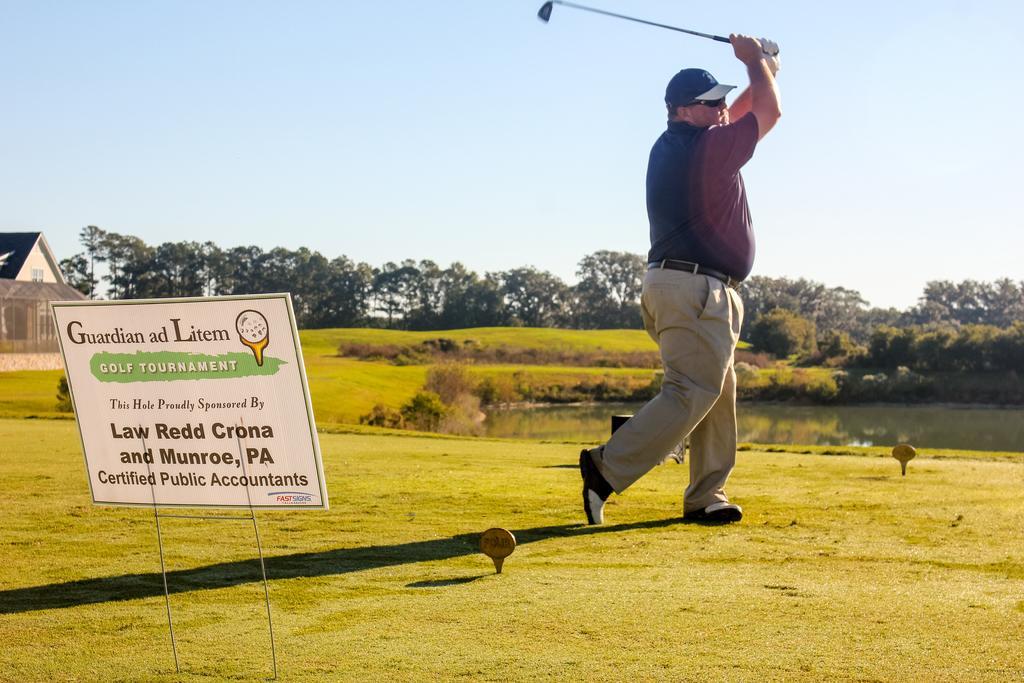In one or two sentences, can you explain what this image depicts? In the left side it is a board, in the middle a man is standing and playing the golf. He wore a shirt, trouser. In the right side it is water, in the long back side there are trees. 